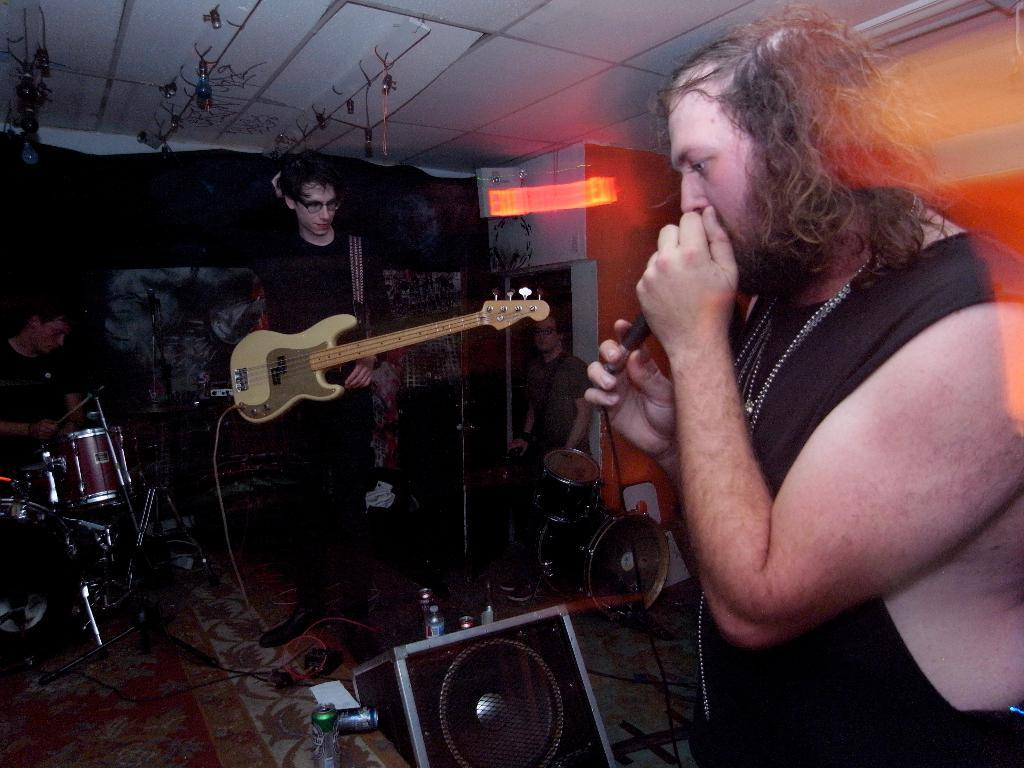How many people are in the image? There are four people in the image. What are the people doing in the image? The people are playing musical instruments. How many monkeys are in the crowd in the image? There are no monkeys or crowds present in the image; it features four people playing musical instruments. 